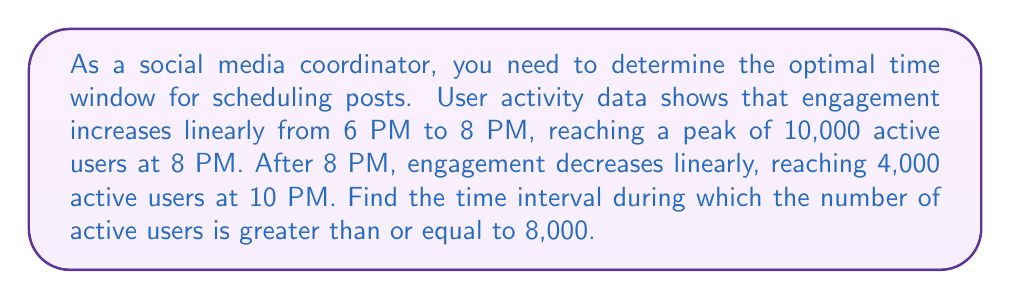Help me with this question. Let's approach this step-by-step:

1) First, let's define our variables:
   $t$ = time (in hours after 6 PM)
   $y$ = number of active users

2) For the increasing linear function from 6 PM to 8 PM:
   Slope $m_1 = \frac{10000 - 0}{2 - 0} = 5000$ users/hour
   Equation: $y = 5000t$

3) For the decreasing linear function from 8 PM to 10 PM:
   Slope $m_2 = \frac{4000 - 10000}{2 - 0} = -3000$ users/hour
   Equation: $y = -3000(t-2) + 10000 = -3000t + 16000$

4) We want to find when $y \geq 8000$ for each function:

   For the increasing function:
   $5000t \geq 8000$
   $t \geq 1.6$

   For the decreasing function:
   $-3000t + 16000 \geq 8000$
   $-3000t \geq -8000$
   $t \leq \frac{8}{3} \approx 2.67$

5) Converting back to clock time:
   1.6 hours after 6 PM is 7:36 PM
   2.67 hours after 6 PM is 8:40 PM

Therefore, the number of active users is greater than or equal to 8,000 from 7:36 PM to 8:40 PM.
Answer: 7:36 PM to 8:40 PM 